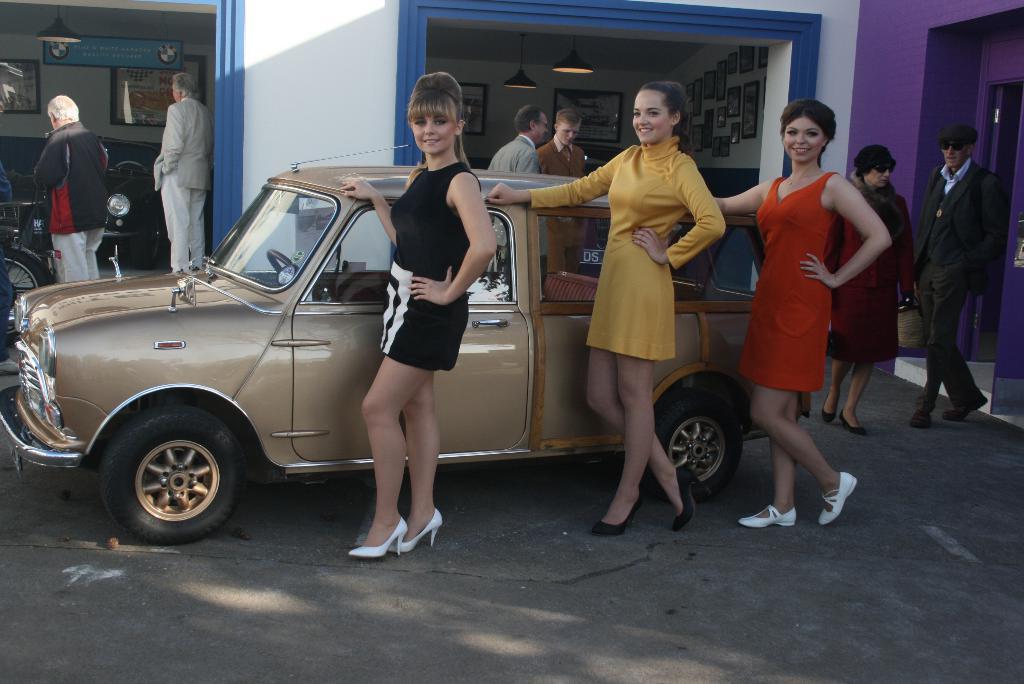Please provide a concise description of this image. In this image there are three women standing and smiling, there are vehicles, group of people standing, frames attached to the wall, lights. 